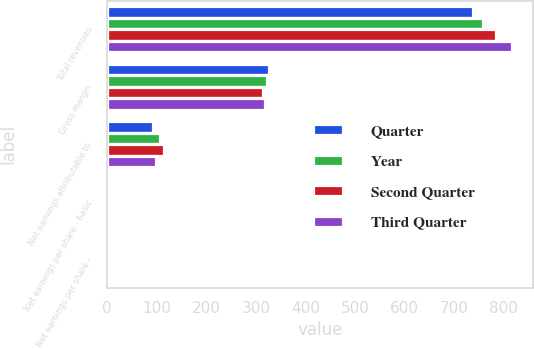Convert chart. <chart><loc_0><loc_0><loc_500><loc_500><stacked_bar_chart><ecel><fcel>Total revenues<fcel>Gross margin<fcel>Net earnings attributable to<fcel>Net earnings per share - basic<fcel>Net earnings per share -<nl><fcel>Quarter<fcel>737.9<fcel>327<fcel>93.3<fcel>0.93<fcel>0.92<nl><fcel>Year<fcel>759.4<fcel>322.5<fcel>106<fcel>1.06<fcel>1.05<nl><fcel>Second Quarter<fcel>784<fcel>315<fcel>113.5<fcel>1.14<fcel>1.13<nl><fcel>Third Quarter<fcel>817.8<fcel>318.2<fcel>98.7<fcel>1<fcel>0.99<nl></chart> 